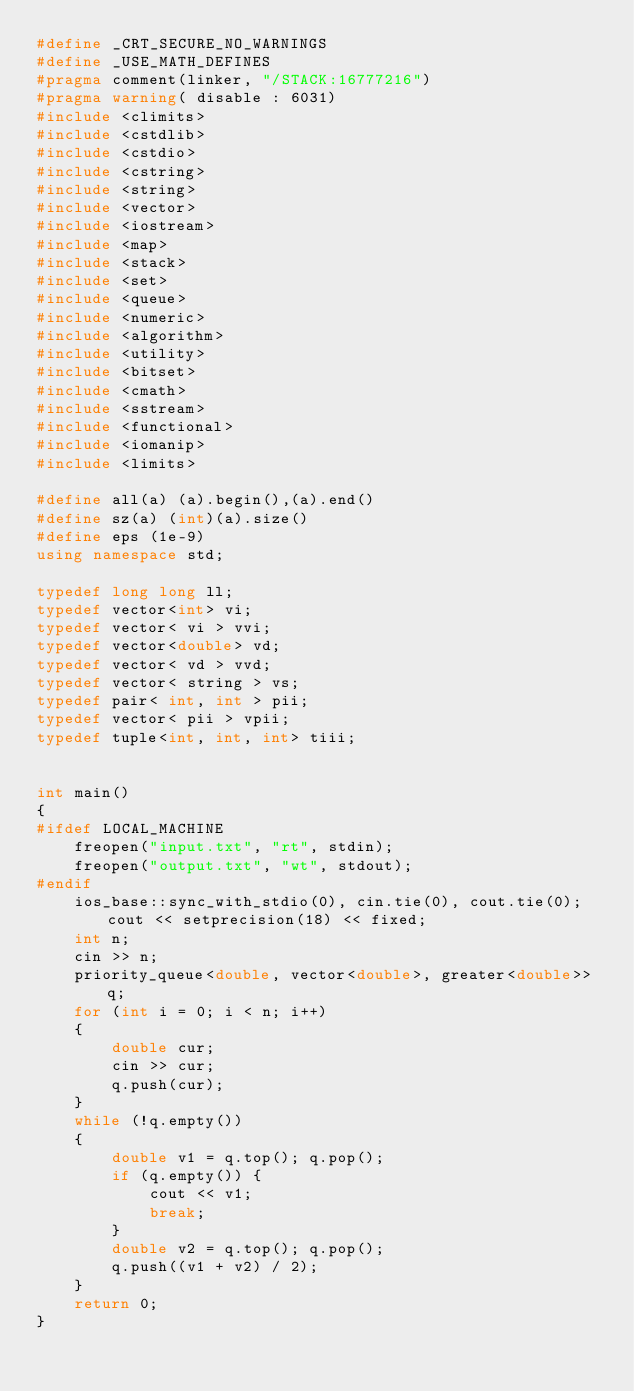<code> <loc_0><loc_0><loc_500><loc_500><_C++_>#define _CRT_SECURE_NO_WARNINGS
#define _USE_MATH_DEFINES
#pragma comment(linker, "/STACK:16777216")
#pragma warning( disable : 6031)
#include <climits>
#include <cstdlib>
#include <cstdio>
#include <cstring>
#include <string>
#include <vector>
#include <iostream>
#include <map>
#include <stack>
#include <set>
#include <queue>
#include <numeric>
#include <algorithm>
#include <utility>
#include <bitset>
#include <cmath>
#include <sstream>
#include <functional>
#include <iomanip>
#include <limits>

#define all(a) (a).begin(),(a).end()
#define sz(a) (int)(a).size()
#define eps (1e-9)
using namespace std;

typedef long long ll;
typedef vector<int> vi;
typedef vector< vi > vvi;
typedef vector<double> vd;
typedef vector< vd > vvd;
typedef vector< string > vs;
typedef pair< int, int > pii;
typedef vector< pii > vpii;
typedef tuple<int, int, int> tiii;


int main()
{
#ifdef LOCAL_MACHINE
	freopen("input.txt", "rt", stdin);
	freopen("output.txt", "wt", stdout);
#endif
	ios_base::sync_with_stdio(0), cin.tie(0), cout.tie(0); cout << setprecision(18) << fixed;
	int n;
	cin >> n;
	priority_queue<double, vector<double>, greater<double>> q;
	for (int i = 0; i < n; i++)
	{
		double cur;
		cin >> cur;
		q.push(cur);
	}
	while (!q.empty())
	{
		double v1 = q.top(); q.pop();
		if (q.empty()) {
			cout << v1;
			break;
		}
		double v2 = q.top(); q.pop();
		q.push((v1 + v2) / 2);
	}
	return 0;
}</code> 